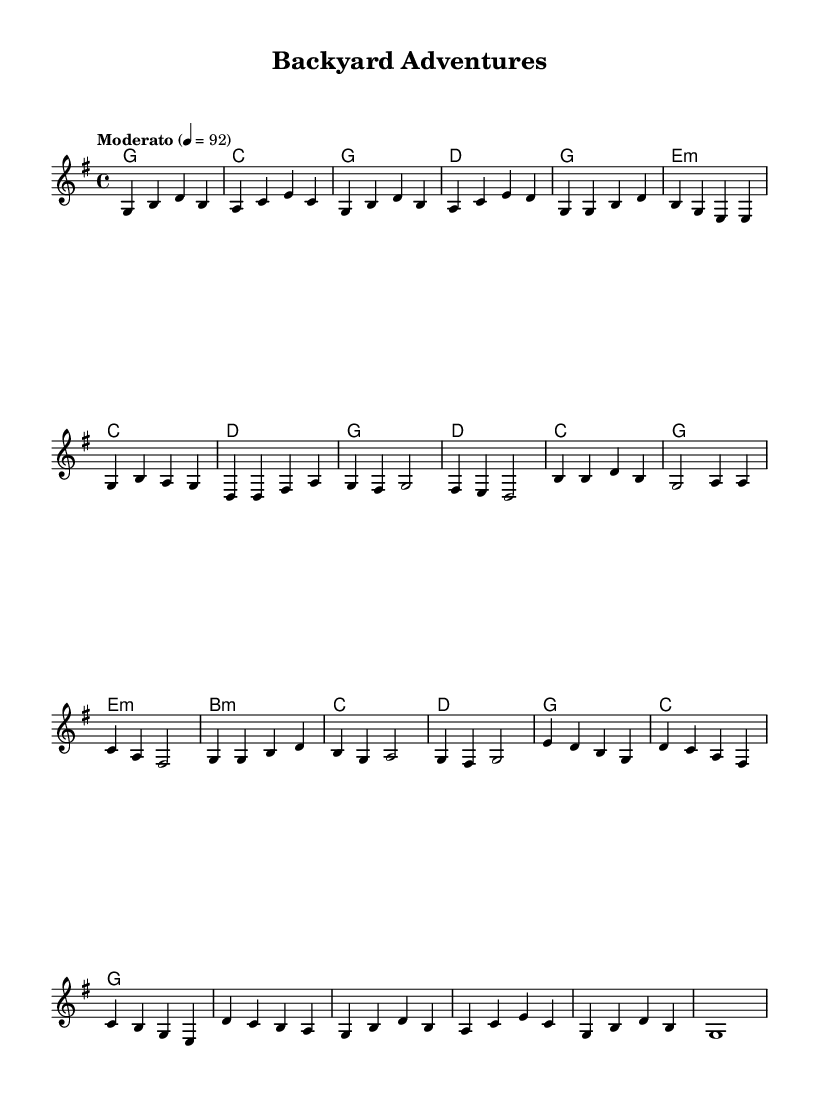What is the key signature of this music? The key signature indicates one sharp (F#), common in G major. It can be seen at the start of the staff.
Answer: G major What is the time signature of this music? The time signature is found at the beginning of the score, showing four beats per measure, which is indicated by the 4/4 notation.
Answer: 4/4 What is the tempo marking of the piece? The tempo marking is indicated in the score with the word "Moderato" followed by a tempo of quarter note = 92, found at the start of the piece.
Answer: Moderato How many measures are in the chorus section? The chorus consists of four measures, as indicated by the groupings of the notes in that part of the sheet music. Each grouping represents one measure.
Answer: 4 What is the first chord in the outro? The first chord in the outro section can be identified at the beginning of the section where it shows a G major chord in the chord notation.
Answer: G Which section includes a bridge? The bridge section is denoted by the unique musical phrase that follows the chorus and is explicitly labeled as "Bridge" above that part of the score.
Answer: Bridge 